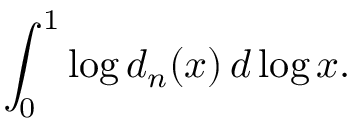<formula> <loc_0><loc_0><loc_500><loc_500>\int _ { 0 } ^ { 1 } \log d _ { n } ( x ) \, d \log x .</formula> 